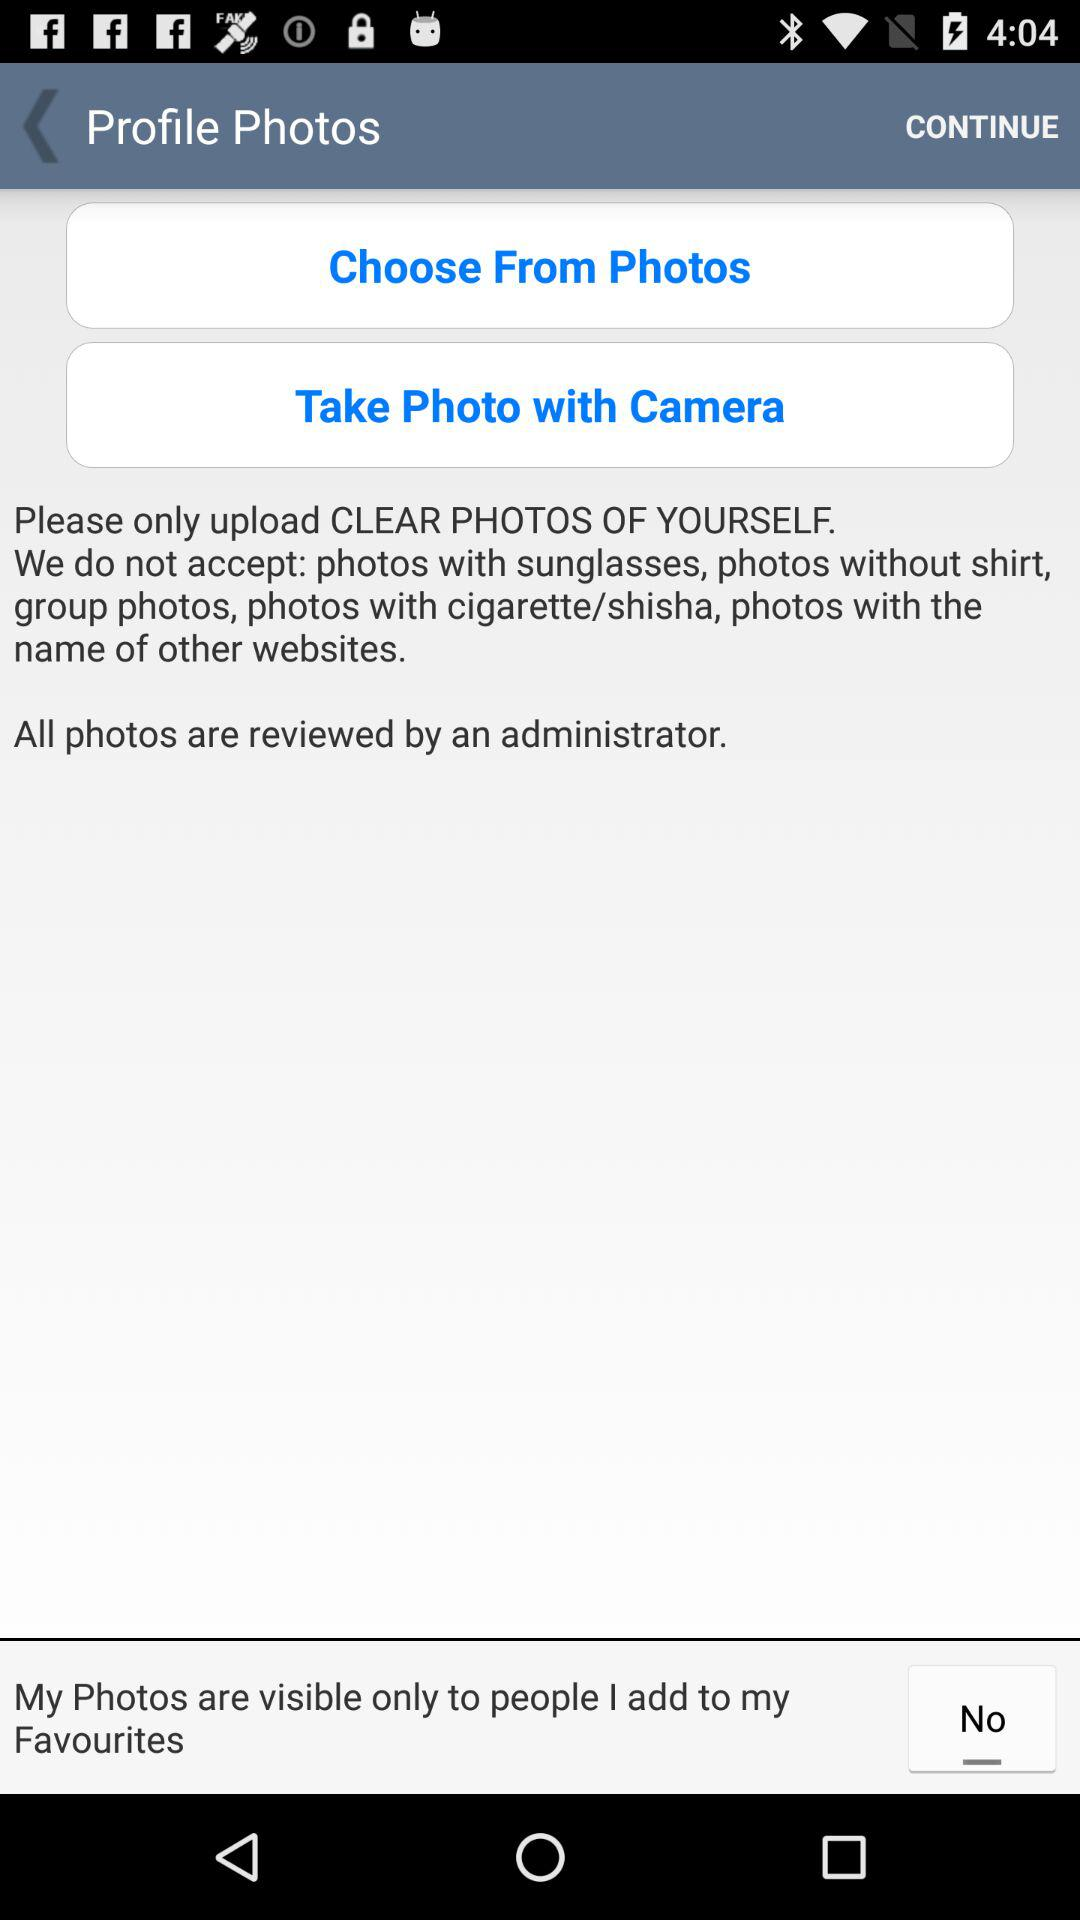What are the two options available for choosing the profile photo? The options available for choosing the profile photo are "Choose From Photos" and "Take Photos with Camera". 